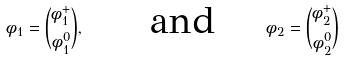Convert formula to latex. <formula><loc_0><loc_0><loc_500><loc_500>\phi _ { 1 } = \binom { \phi _ { 1 } ^ { + } } { \phi _ { 1 } ^ { 0 } } , \text { \quad \ and \quad } \phi _ { 2 } = \binom { \phi _ { 2 } ^ { + } } { \phi _ { 2 } ^ { 0 } }</formula> 